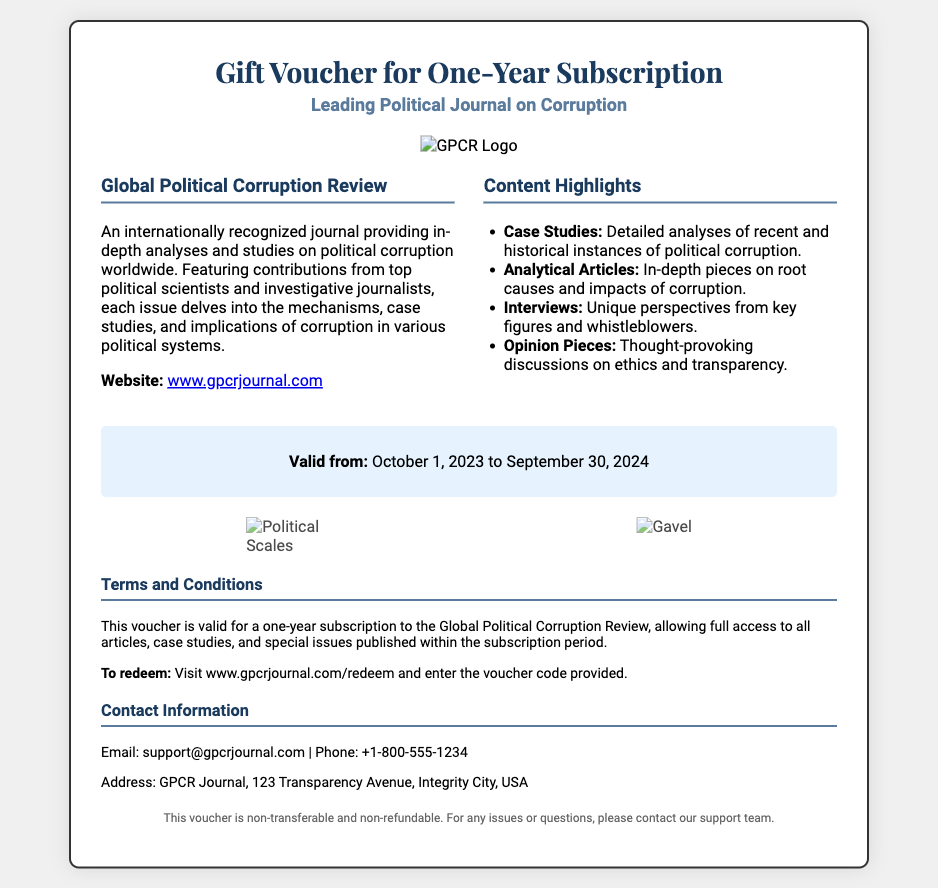What is the name of the journal featured in the voucher? The name of the journal is prominently mentioned in the document as "Global Political Corruption Review."
Answer: Global Political Corruption Review What is the validity period of the voucher? The validity period states that it is valid from October 1, 2023 to September 30, 2024.
Answer: October 1, 2023 to September 30, 2024 What type of subscription does this voucher offer? The voucher provides a one-year subscription to an in-depth political journal.
Answer: One-year subscription What website can the journal be accessed through? The document provides the website link as part of the journal information.
Answer: www.gpcrjournal.com List one type of content highlight included in the journal. The document lists multiple highlights including case studies, analytical articles, interviews, and opinion pieces.
Answer: Case Studies What must be entered to redeem the voucher? To redeem the voucher, one must enter the voucher code provided on the specified website.
Answer: Voucher code Who can be contacted for support regarding this voucher? The contact information includes an email and phone number for support, which can be found in the "Contact Information" section.
Answer: support@gpcrjournal.com What does the voucher state about its transferability? The document clearly states that "This voucher is non-transferable and non-refundable."
Answer: Non-transferable What kind of images are displayed in the voucher? The images included in the voucher are related to political themes, such as political scales and a gavel.
Answer: Political scales and gavel 